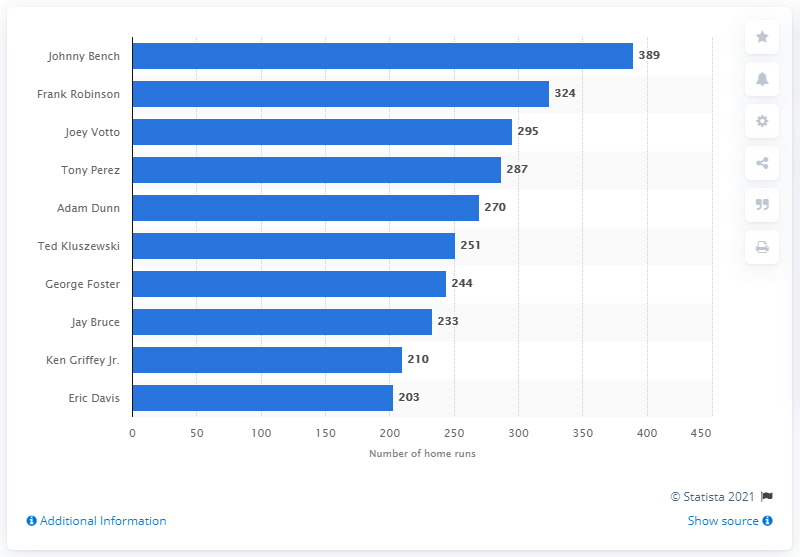List a handful of essential elements in this visual. The difference in home runs between the top two home run leaders for the Reds is 65. Which Reds player has hit the third most home runs for them? It is none other than the esteemed Joey Votto. The Cincinnati Reds franchise has seen numerous home run hitters throughout its history, but none have hit more home runs than Johnny Bench. Johnny Bench, a renowned baseball player, has hit a total of 389 home runs during his illustrious career. 